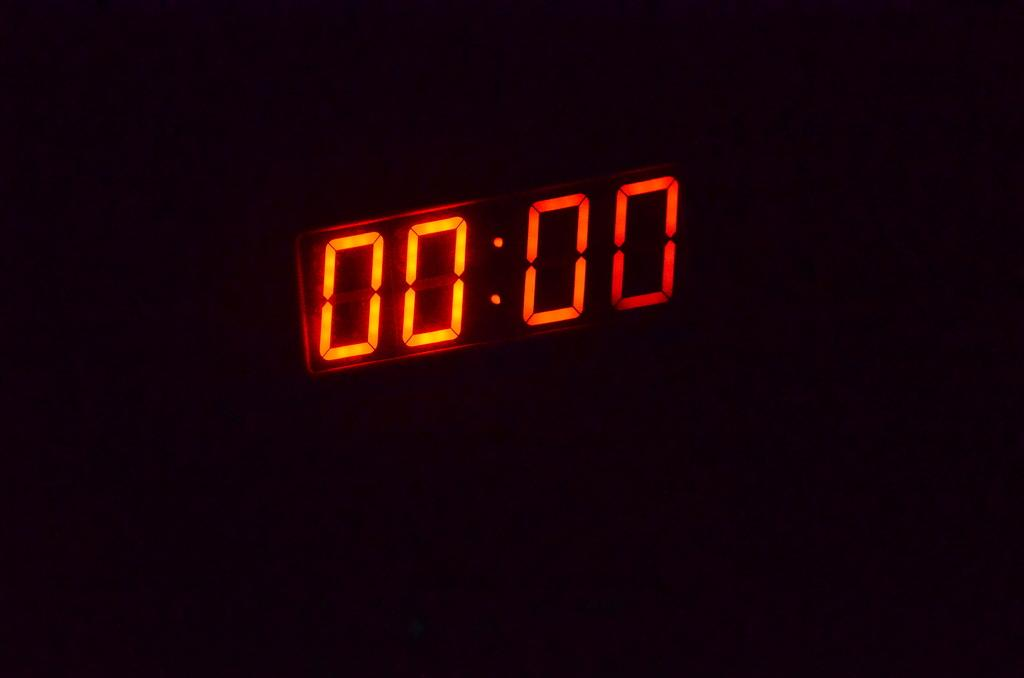What type of device is visible in the image? There is a digital clock in the image. Can you describe the background of the image? The background of the image is dark. What type of crate is used for acoustics in the image? There is no crate or mention of acoustics in the image; it only features a digital clock with a dark background. 